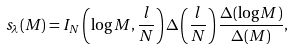Convert formula to latex. <formula><loc_0><loc_0><loc_500><loc_500>s _ { \lambda } ( M ) = I _ { N } \left ( \log M , \frac { l } { N } \right ) \Delta \left ( \frac { l } { N } \right ) \frac { \Delta ( \log M ) } { \Delta ( M ) } ,</formula> 